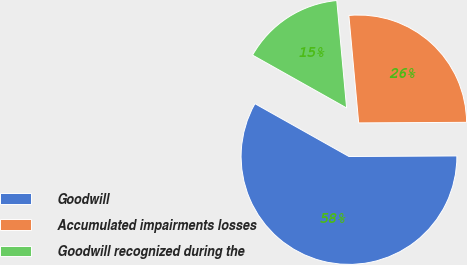Convert chart to OTSL. <chart><loc_0><loc_0><loc_500><loc_500><pie_chart><fcel>Goodwill<fcel>Accumulated impairments losses<fcel>Goodwill recognized during the<nl><fcel>58.24%<fcel>26.37%<fcel>15.4%<nl></chart> 